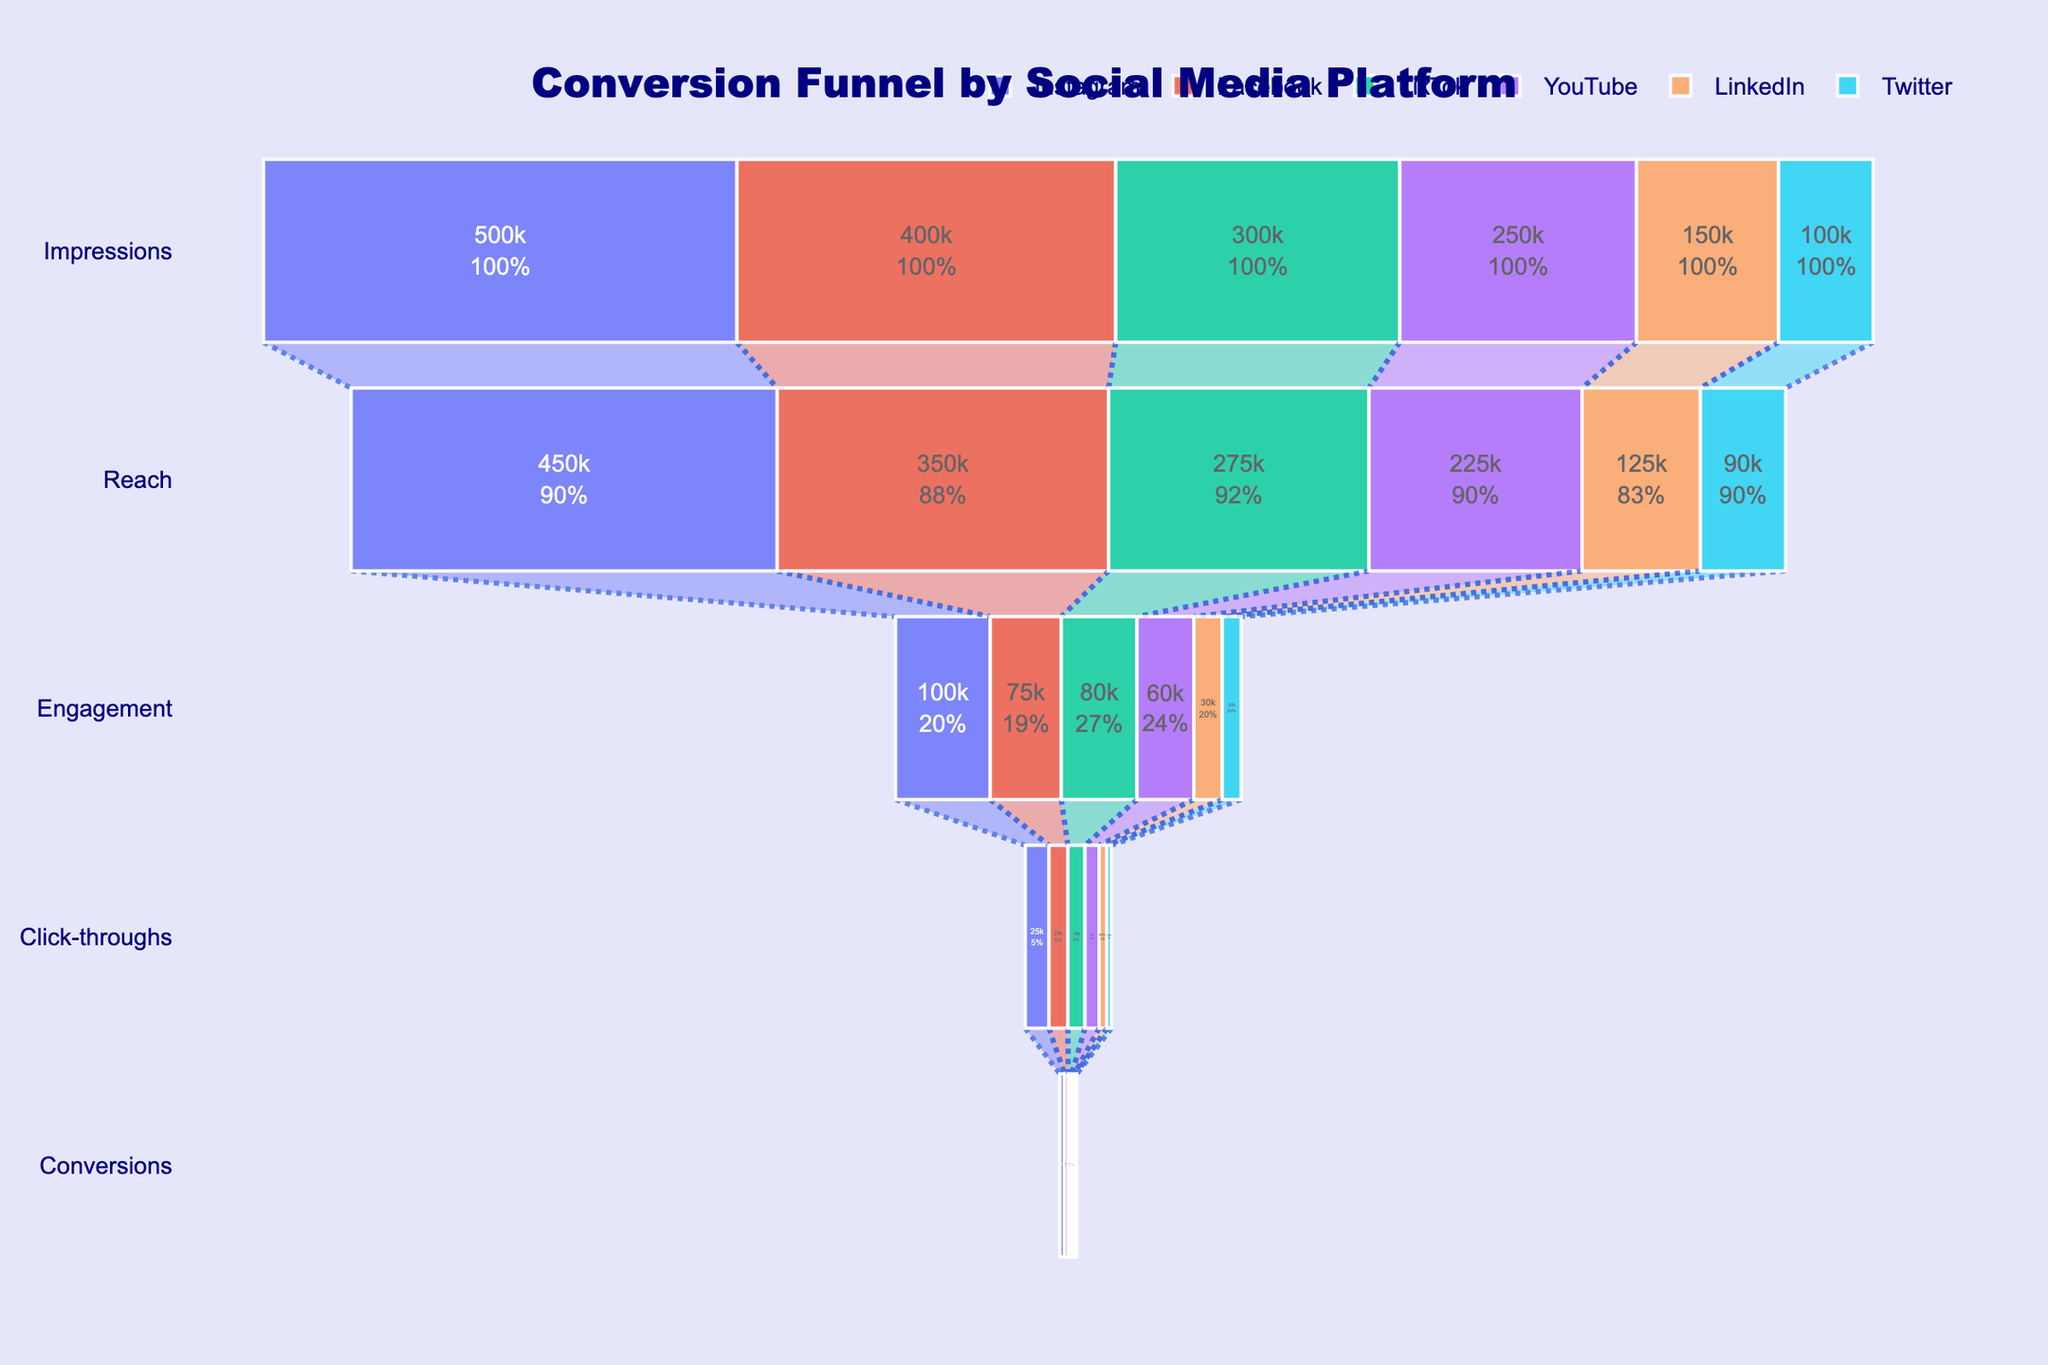What is the title of the figure? The title is displayed at the top center of the chart and reads: "Conversion Funnel by Social Media Platform".
Answer: Conversion Funnel by Social Media Platform How many stages are shown in each funnel? The chart visually divides each funnel into clear stages: Impressions, Reach, Engagement, Click-throughs, and Conversions, totaling 5 stages.
Answer: 5 Which platform has the highest number of Impressions? By looking at the topmost level (Impressions) of each funnel, the platform with the highest value is Instagram with 500,000 Impressions.
Answer: Instagram Compare the Reach stages of Facebook and LinkedIn. Which one is higher and by how much? Facebook's Reach is 350,000 and LinkedIn's Reach is 125,000. Subtract LinkedIn's Reach from Facebook's (350,000 - 125,000) to find Facebook's Reach is higher by 225,000.
Answer: Facebook, by 225,000 What is the overall trend observed from Impressions to Conversions for each platform? We observe that, across all platforms, the number decreases from Impressions to Conversions as we move down each funnel stage, indicating a gradual decrease in users through the conversion process.
Answer: Decreasing trend Which platform has the lowest number of Conversions? By looking at the bottommost level (Conversions), Twitter has the lowest number of Conversions with 1,000.
Answer: Twitter How much greater is Instagram's Click-throughs compared to YouTube's Click-throughs? Instagram's Click-throughs are 25,000 and YouTube's are 15,000. The difference is 25,000 - 15,000 = 10,000.
Answer: 10,000 Calculate the average number of Engagements for all platforms. Add the Engagement values for all platforms (100,000 + 75,000 + 80,000 + 60,000 + 30,000 + 20,000 = 365,000) and divide by the number of platforms (6). So, 365,000 / 6 ≈ 60,833.33.
Answer: ≈ 60,833.33 In the Conversions stage, how many platforms have conversions lower than TikTok? TikTok has 3,500 Conversions. Platforms with lower Conversions are YouTube (3,000), LinkedIn (1,500), and Twitter (1,000), totaling 3 platforms.
Answer: 3 What percentage of Impressions convert to Reach for Facebook? Facebook's Impressions are 400,000 and Reach is 350,000. The percentage conversion from Impressions to Reach is (350,000 / 400,000) * 100 = 87.5%.
Answer: 87.5% 